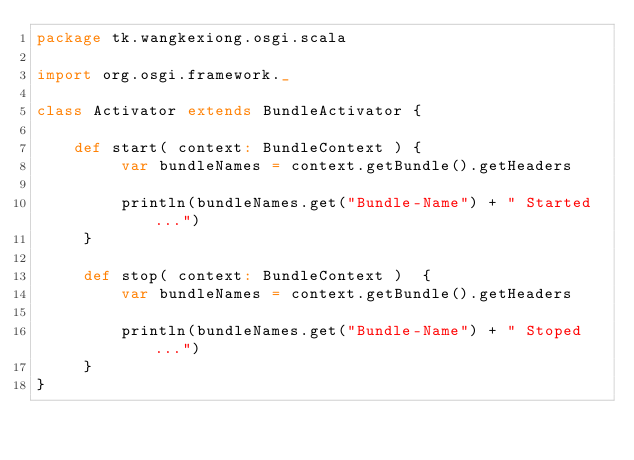Convert code to text. <code><loc_0><loc_0><loc_500><loc_500><_Scala_>package tk.wangkexiong.osgi.scala

import org.osgi.framework._

class Activator extends BundleActivator {

    def start( context: BundleContext ) {
         var bundleNames = context.getBundle().getHeaders
          
         println(bundleNames.get("Bundle-Name") + " Started ...")
     }

     def stop( context: BundleContext )  {
         var bundleNames = context.getBundle().getHeaders
          
         println(bundleNames.get("Bundle-Name") + " Stoped ...")
     }
}
</code> 